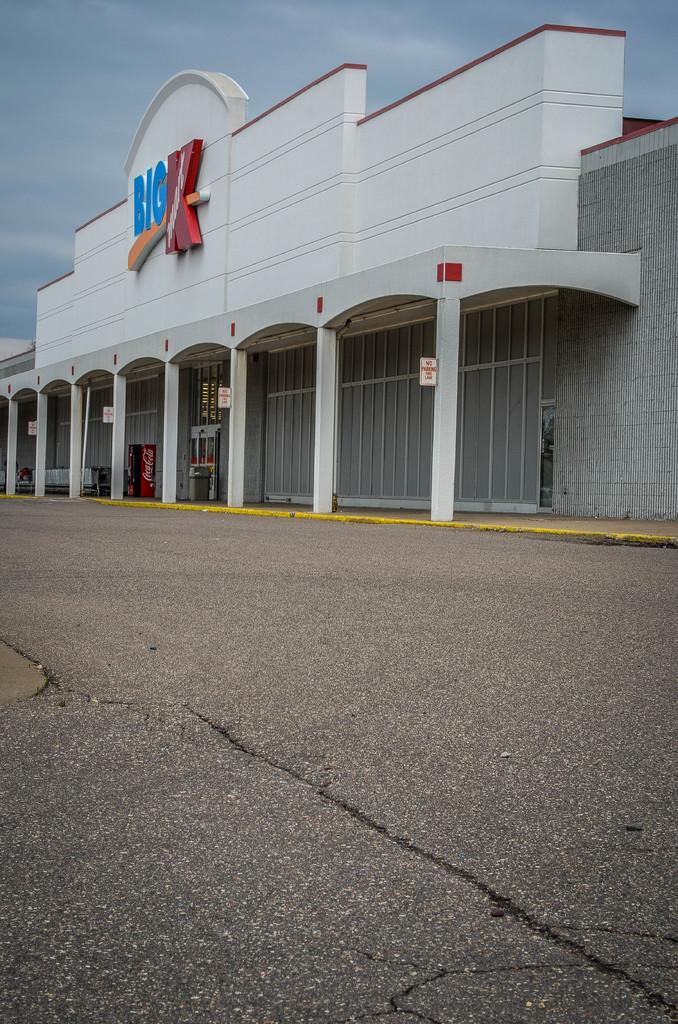What type of pathway is present in the image? There is a road in the image. What type of structure can be seen in the image? There is a building in the image. What objects are visible in the image that might be used for displaying information or advertisements? Boards are visible in the image. What part of the natural environment is visible in the image? The sky is visible in the image. What type of written communication is present in the image? There is text written on something in the image. How many ladybugs can be seen crawling on the door in the image? There is no door or ladybugs present in the image. What type of pest is visible on the boards in the image? There are no pests visible on the boards in the image. 